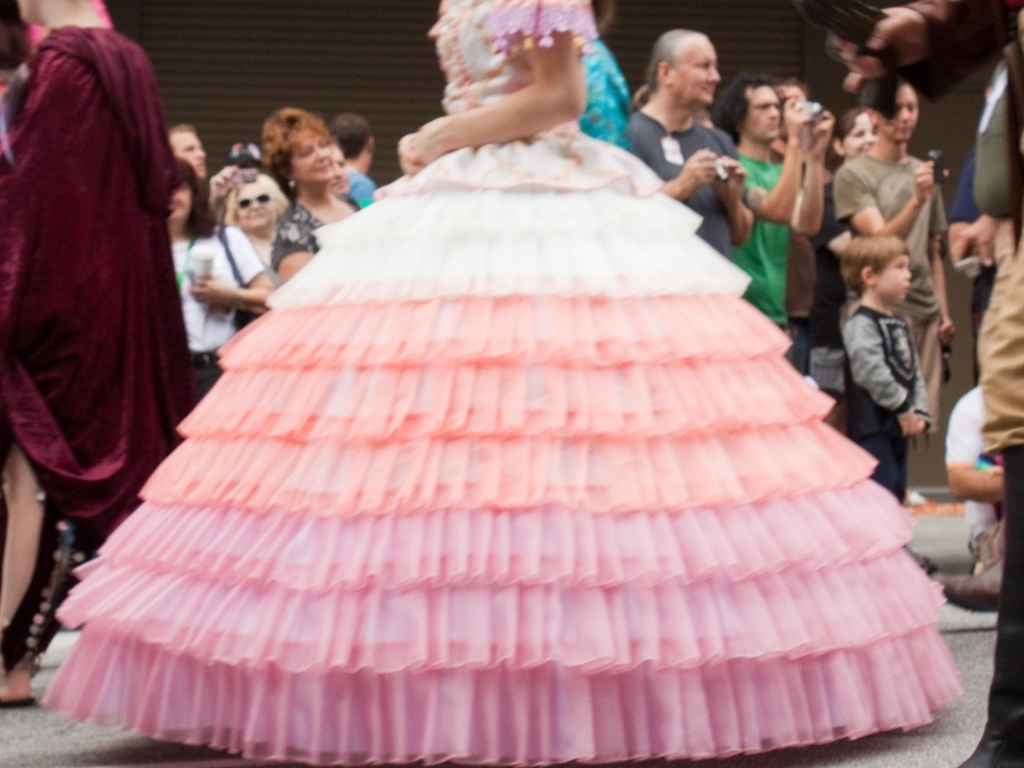Are there any quality issues with this image? Yes, the image is blurred, which affects the overall sharpness and detail. It's possible that this was due to camera movement or a slow shutter speed during capture. Additionally, the composition of the photo cuts off part of the subject on the left side, which may not be intentional and can detract from the image's intended message or aesthetic balance. 